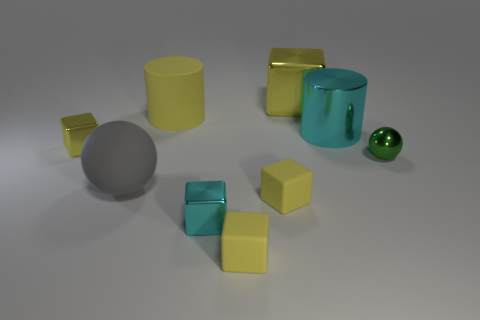Subtract all yellow cubes. How many were subtracted if there are2yellow cubes left? 2 Subtract all cyan cylinders. How many yellow blocks are left? 4 Subtract all cyan blocks. How many blocks are left? 4 Subtract all cyan cubes. How many cubes are left? 4 Subtract all red blocks. Subtract all purple balls. How many blocks are left? 5 Add 1 cyan balls. How many objects exist? 10 Subtract all cylinders. How many objects are left? 7 Subtract 1 gray spheres. How many objects are left? 8 Subtract all large gray rubber cubes. Subtract all metal things. How many objects are left? 4 Add 7 large gray objects. How many large gray objects are left? 8 